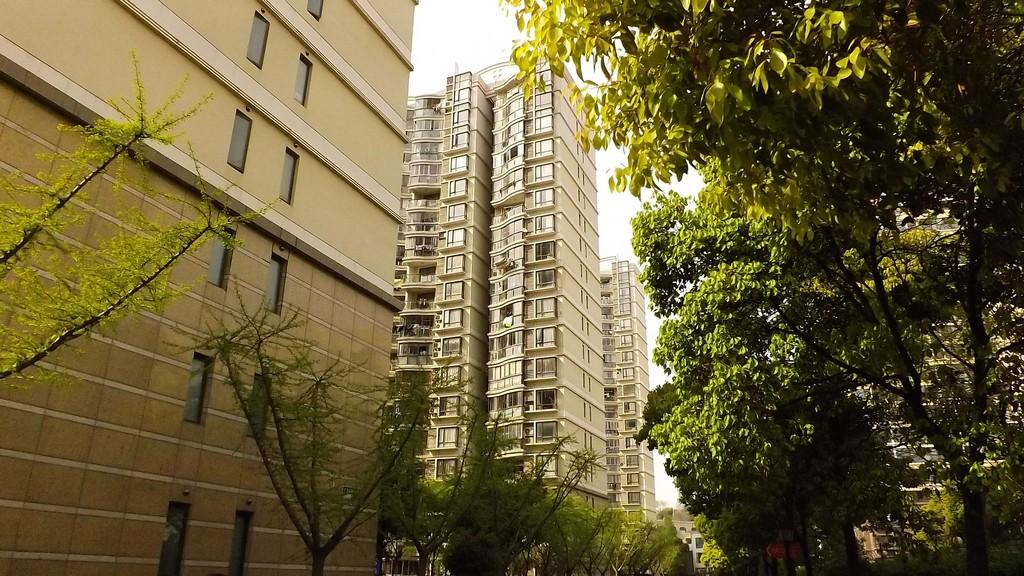What type of structures can be seen in the image? There are buildings in the image. What natural elements are present in the image? There are trees in the image. What object can be seen standing upright in the image? There is a pole in the image. What flat surface with writing or images can be seen in the image? There is a board in the image. What can be seen in the background of the image? The sky is visible in the background of the image. What type of jeans is the person wearing in the image? There is no person or jeans present in the image. How many matches are visible on the board in the image? There are no matches present in the image; it features a board but no matches. 